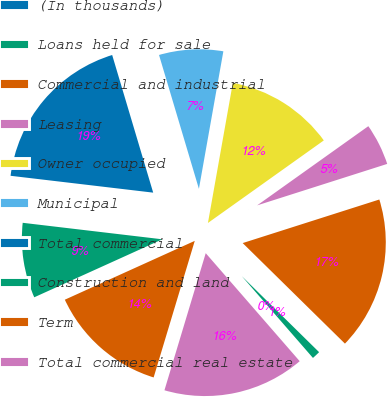Convert chart. <chart><loc_0><loc_0><loc_500><loc_500><pie_chart><fcel>(In thousands)<fcel>Loans held for sale<fcel>Commercial and industrial<fcel>Leasing<fcel>Owner occupied<fcel>Municipal<fcel>Total commercial<fcel>Construction and land<fcel>Term<fcel>Total commercial real estate<nl><fcel>0.0%<fcel>1.24%<fcel>17.28%<fcel>4.94%<fcel>12.35%<fcel>7.41%<fcel>18.52%<fcel>8.64%<fcel>13.58%<fcel>16.05%<nl></chart> 